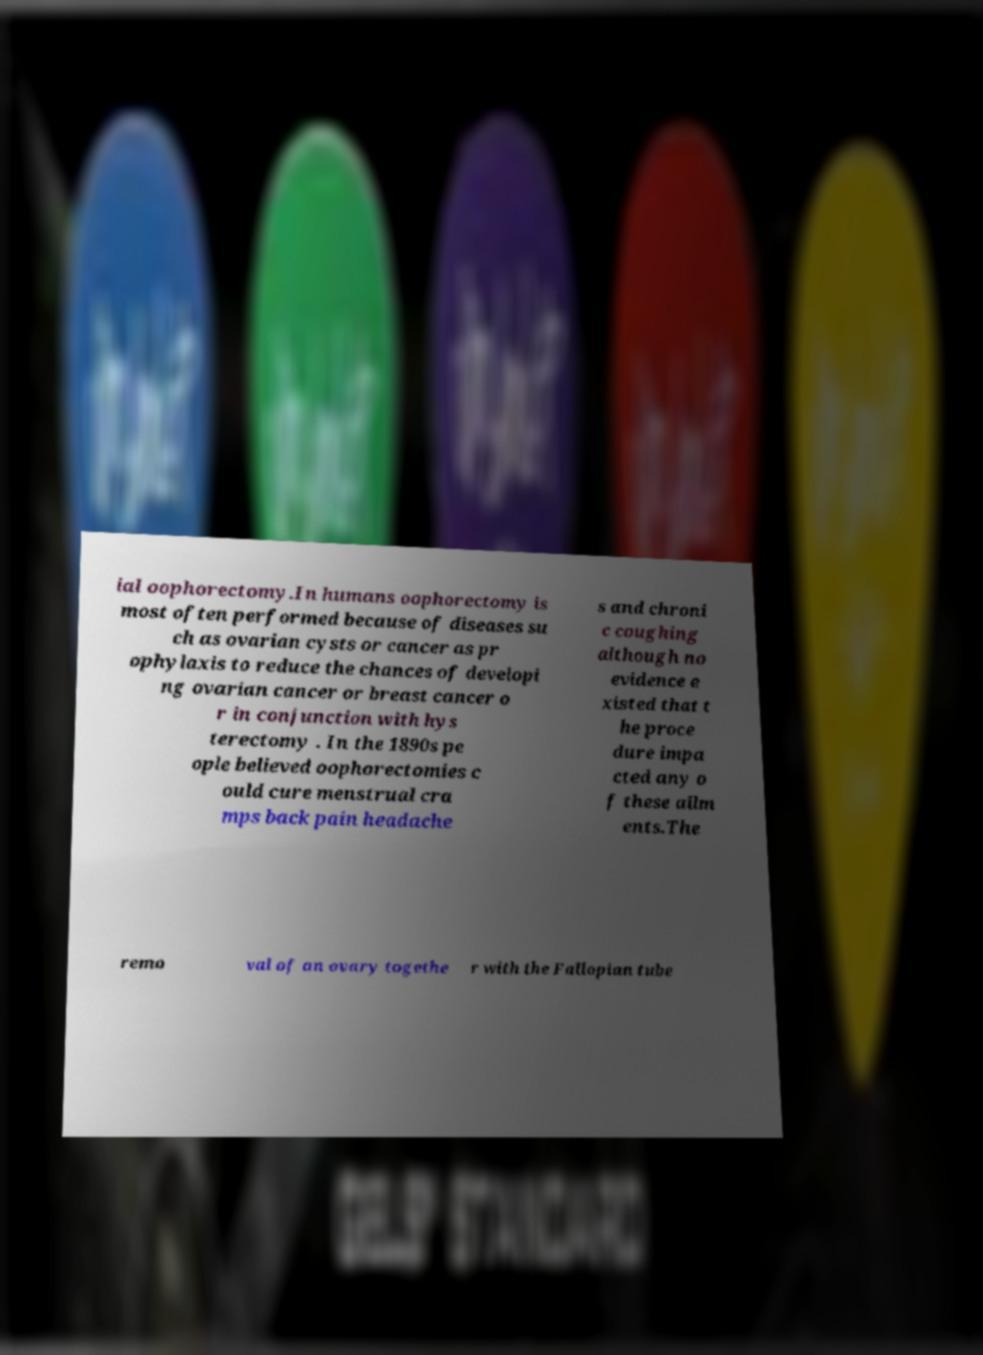Please identify and transcribe the text found in this image. ial oophorectomy.In humans oophorectomy is most often performed because of diseases su ch as ovarian cysts or cancer as pr ophylaxis to reduce the chances of developi ng ovarian cancer or breast cancer o r in conjunction with hys terectomy . In the 1890s pe ople believed oophorectomies c ould cure menstrual cra mps back pain headache s and chroni c coughing although no evidence e xisted that t he proce dure impa cted any o f these ailm ents.The remo val of an ovary togethe r with the Fallopian tube 